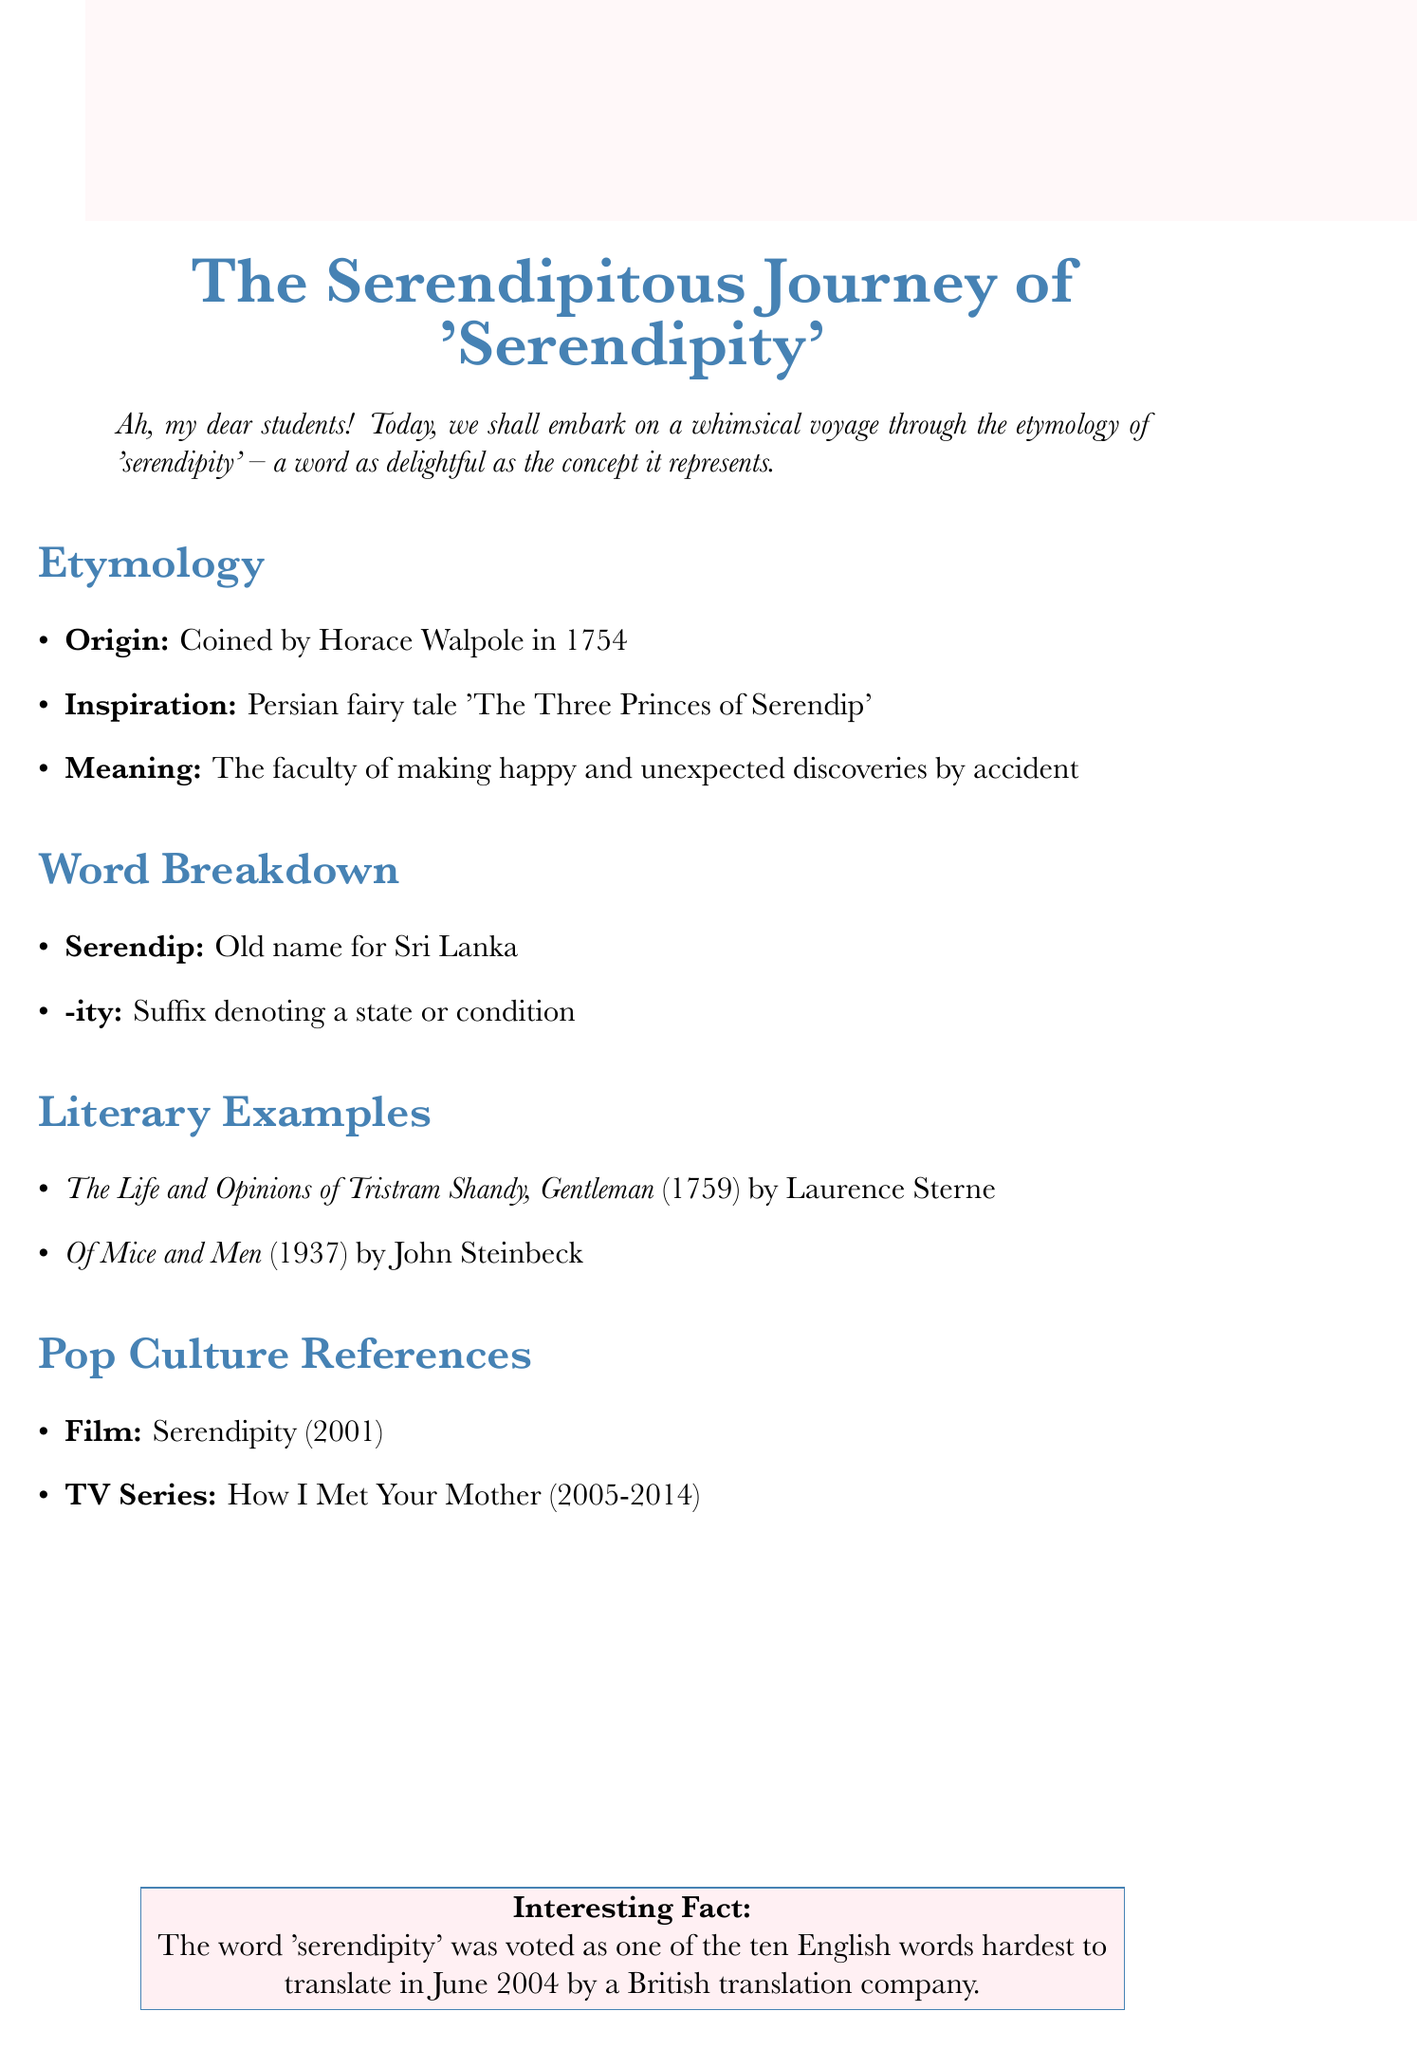What year was the word 'serendipity' coined? The document states that 'serendipity' was coined by Horace Walpole in 1754.
Answer: 1754 Who is the author of 'The Life and Opinions of Tristram Shandy, Gentleman'? According to the literary examples section, Laurence Sterne is the author of this work.
Answer: Laurence Sterne What type of culture reference is 'Serendipity' (2001)? The document categorizes 'Serendipity' as a film.
Answer: Film What is the inspiration for the word 'serendipity'? The document mentions that the inspiration comes from the Persian fairy tale 'The Three Princes of Serendip'.
Answer: The Three Princes of Serendip What does the suffix '-ity' denote? The word breakdown section explains that the suffix '-ity' denotes a state or condition.
Answer: A state or condition What literary work is considered one of the earliest examples of serendipity in literature? The document identifies 'The Life and Opinions of Tristram Shandy, Gentleman' as one of the earliest examples.
Answer: The Life and Opinions of Tristram Shandy, Gentleman During what years did 'How I Met Your Mother' air? The document specifies that 'How I Met Your Mother' aired from 2005 to 2014.
Answer: 2005-2014 What is an interesting fact about the word 'serendipity'? The document mentions that the word was voted as one of the ten English words hardest to translate in June 2004.
Answer: One of the ten English words hardest to translate 